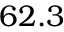<formula> <loc_0><loc_0><loc_500><loc_500>6 2 . 3</formula> 